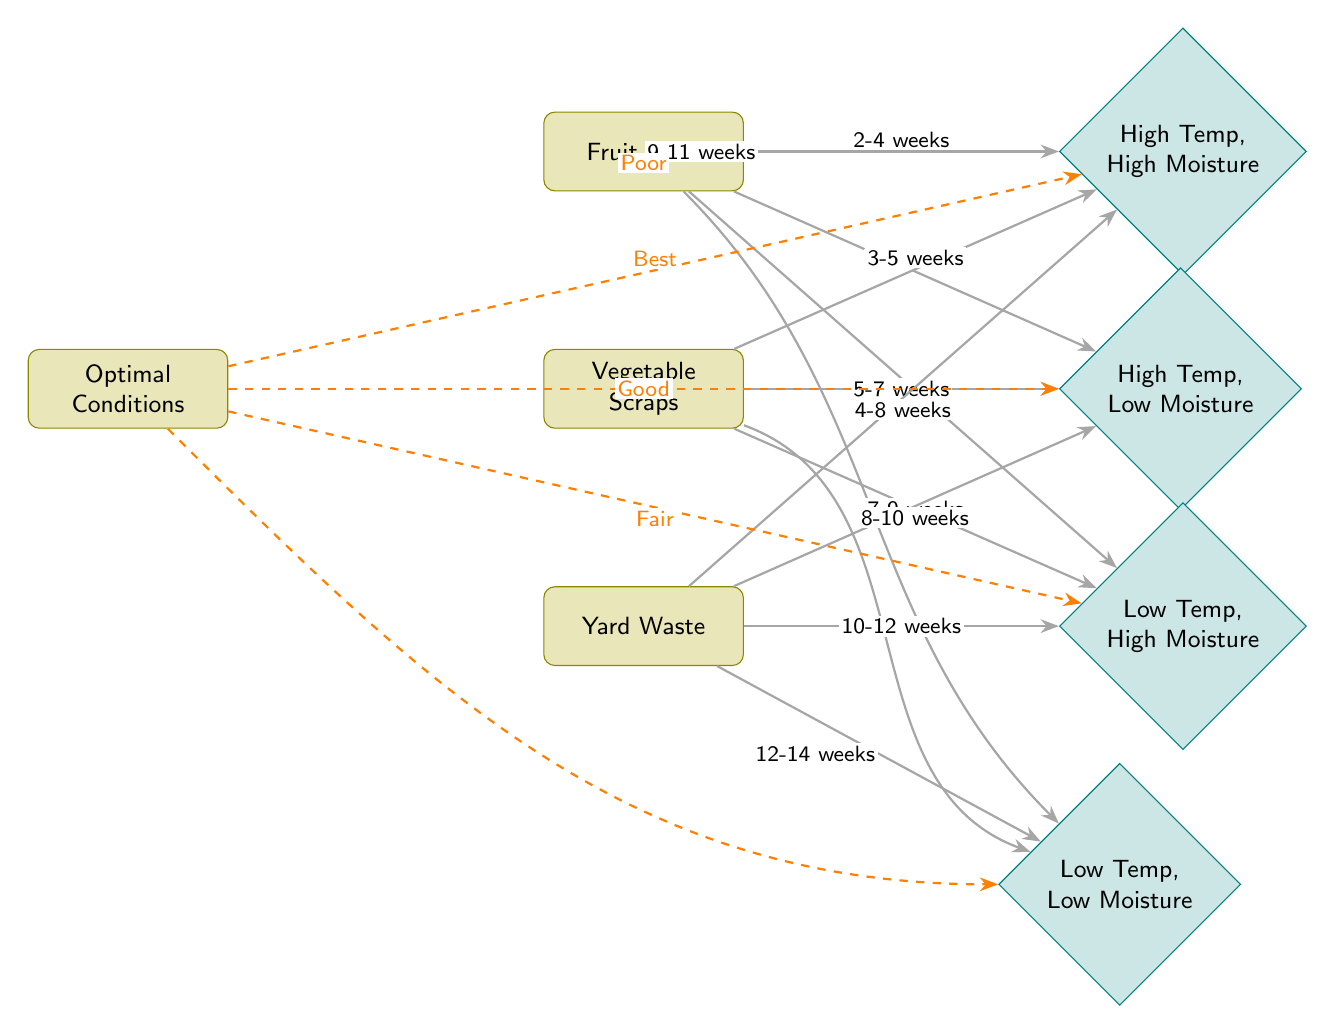What item takes the shortest time to decompose under high temperature and high moisture? The diagram indicates that Fruit Peels decompose in 2-4 weeks under high temperature and high moisture. After evaluating all the items, Fruit Peels has the shortest range of decomposition time in this condition.
Answer: Fruit Peels What are the decomposition timelines for Vegetable Scraps under low temperature and low moisture? Looking at the diagram, Vegetable Scraps take 9-11 weeks to decompose under low temperature and low moisture. The arrow from Vegetable Scraps to the low-low condition specifies this range clearly.
Answer: 9-11 weeks How many weeks does Yard Waste take to decompose under low temperature and high moisture? The diagram shows Yard Waste takes 10-12 weeks to decompose under low temperature and high moisture. This is shown by the connection between Yard Waste and the low-high condition in the diagram.
Answer: 10-12 weeks Which compostable material is the only one that can decompose in 3-5 weeks under optimal conditions? Upon examining the arrows and timelines, it is clear that only Vegetable Scraps can decompose in 3-5 weeks under high temperature and high moisture, linked to the optimal condition arrow in the diagram.
Answer: Vegetable Scraps What is the longest decomposition time for Fruit Peels in any condition shown? From the diagram, under low temperature and low moisture, Fruit Peels can take 8-10 weeks to decompose. This is indicated by the arrow linking Fruit Peels to the low-low condition. Comparing this with the other conditions confirms it is the longest.
Answer: 8-10 weeks What is the best condition for decomposition of materials based on the diagram? The diagram indicates that the best decomposition condition is marked as "Best" leading from Optimal Conditions to High Temperature, High Moisture, representing the quickest overall decomposition environment.
Answer: Best 